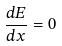<formula> <loc_0><loc_0><loc_500><loc_500>\frac { d E } { d x } = 0</formula> 